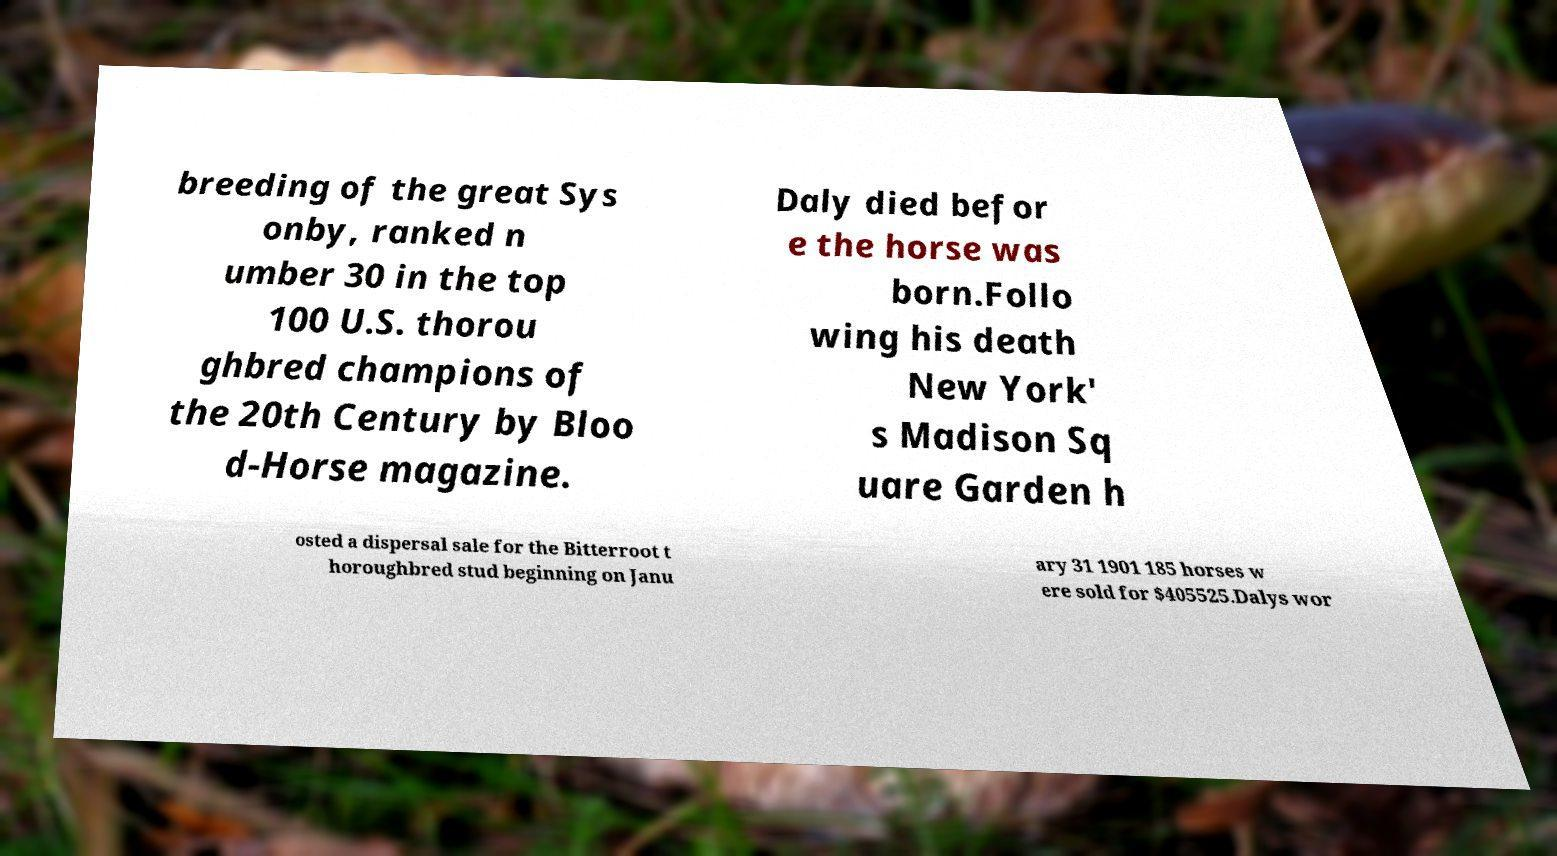Could you extract and type out the text from this image? breeding of the great Sys onby, ranked n umber 30 in the top 100 U.S. thorou ghbred champions of the 20th Century by Bloo d-Horse magazine. Daly died befor e the horse was born.Follo wing his death New York' s Madison Sq uare Garden h osted a dispersal sale for the Bitterroot t horoughbred stud beginning on Janu ary 31 1901 185 horses w ere sold for $405525.Dalys wor 